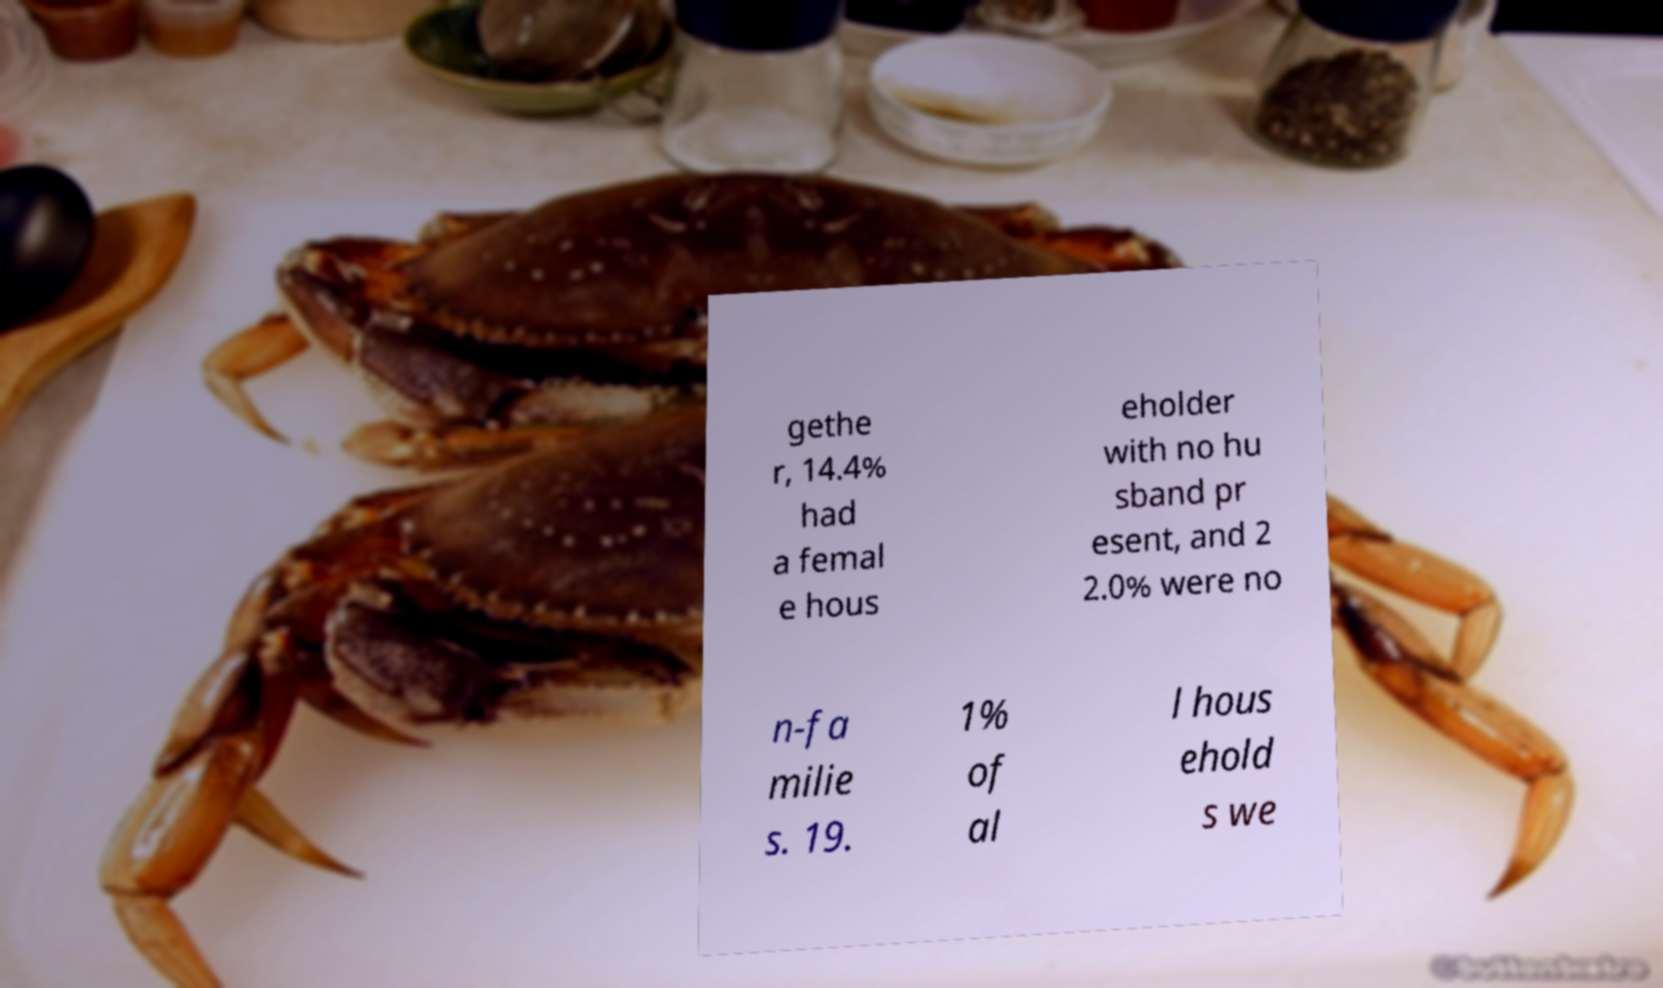Please identify and transcribe the text found in this image. gethe r, 14.4% had a femal e hous eholder with no hu sband pr esent, and 2 2.0% were no n-fa milie s. 19. 1% of al l hous ehold s we 